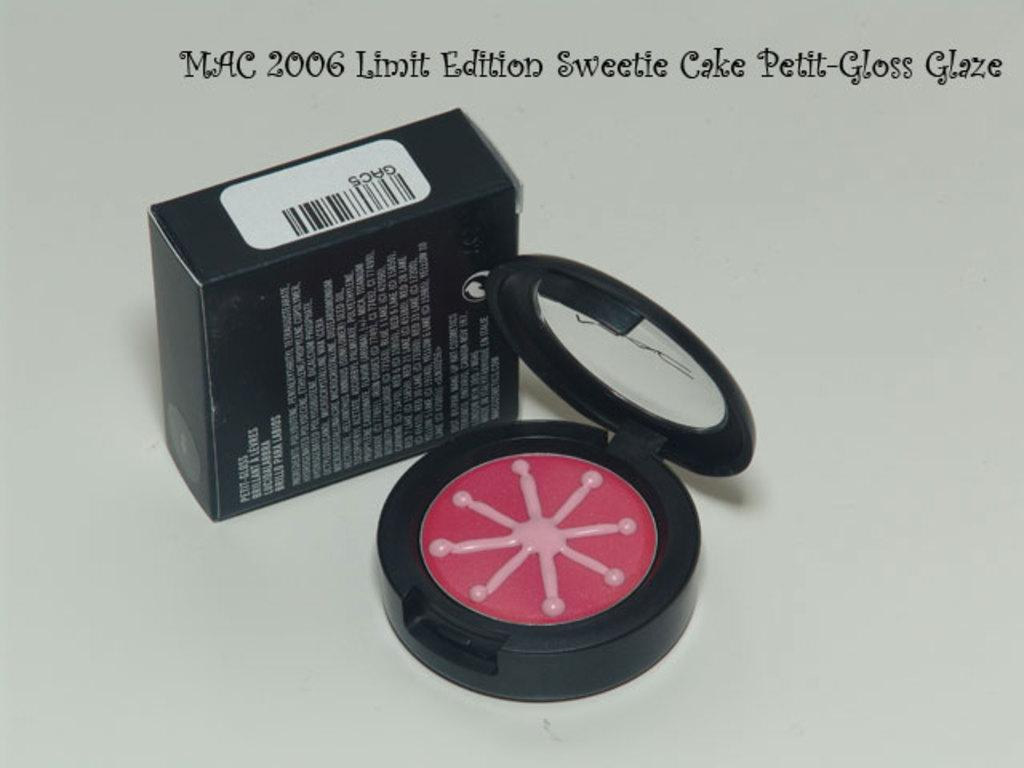<image>
Provide a brief description of the given image. An item which has Mac 2006 Limit Edition written over the top. 